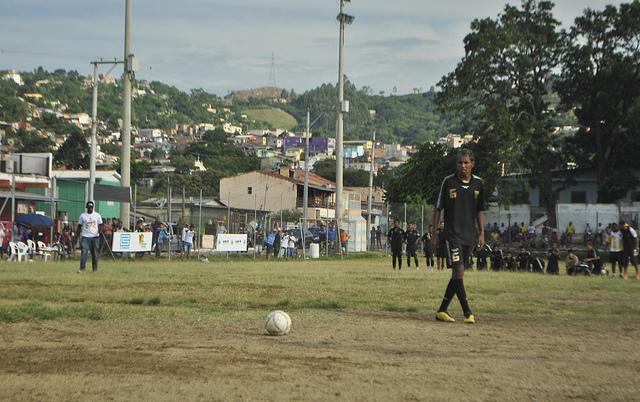How many people are there?
Give a very brief answer. 2. How many bikes are in the picture?
Give a very brief answer. 0. 